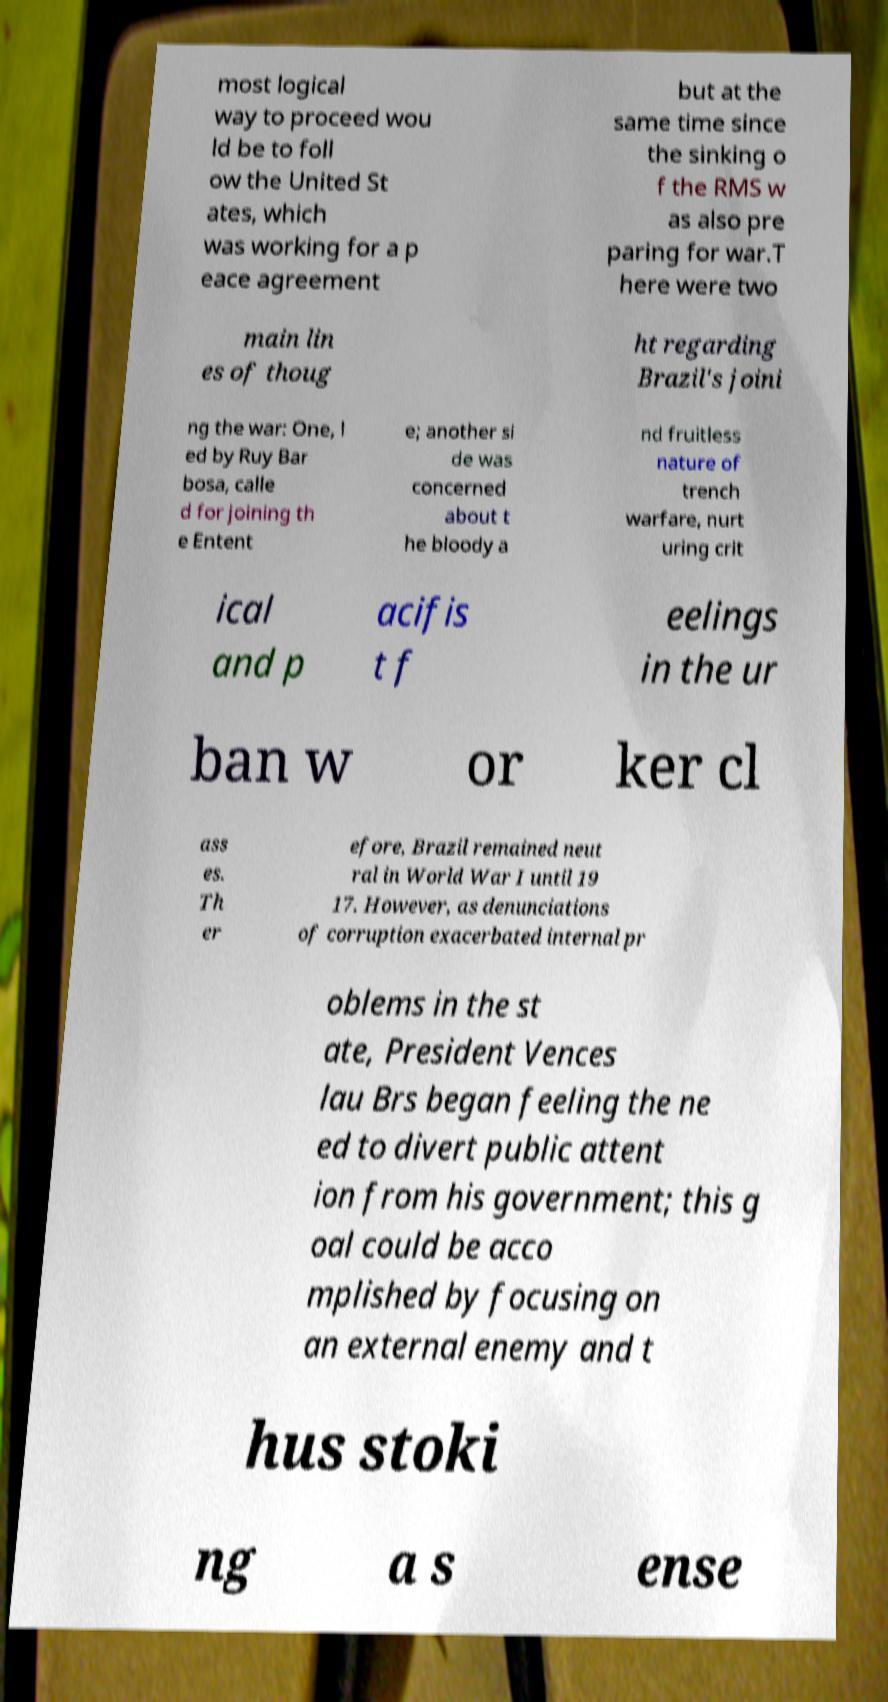What messages or text are displayed in this image? I need them in a readable, typed format. most logical way to proceed wou ld be to foll ow the United St ates, which was working for a p eace agreement but at the same time since the sinking o f the RMS w as also pre paring for war.T here were two main lin es of thoug ht regarding Brazil's joini ng the war: One, l ed by Ruy Bar bosa, calle d for joining th e Entent e; another si de was concerned about t he bloody a nd fruitless nature of trench warfare, nurt uring crit ical and p acifis t f eelings in the ur ban w or ker cl ass es. Th er efore, Brazil remained neut ral in World War I until 19 17. However, as denunciations of corruption exacerbated internal pr oblems in the st ate, President Vences lau Brs began feeling the ne ed to divert public attent ion from his government; this g oal could be acco mplished by focusing on an external enemy and t hus stoki ng a s ense 